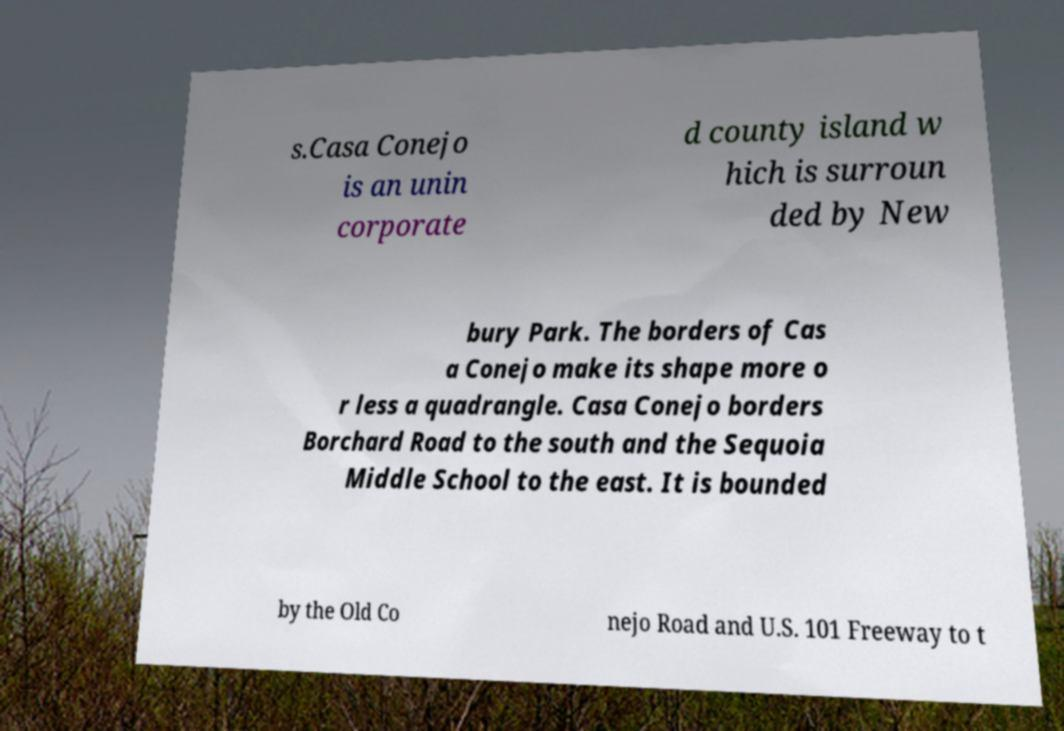What messages or text are displayed in this image? I need them in a readable, typed format. s.Casa Conejo is an unin corporate d county island w hich is surroun ded by New bury Park. The borders of Cas a Conejo make its shape more o r less a quadrangle. Casa Conejo borders Borchard Road to the south and the Sequoia Middle School to the east. It is bounded by the Old Co nejo Road and U.S. 101 Freeway to t 